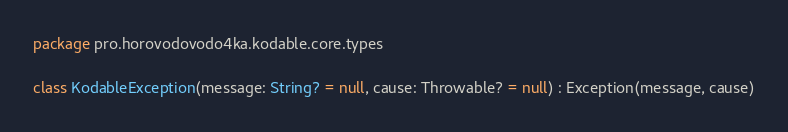Convert code to text. <code><loc_0><loc_0><loc_500><loc_500><_Kotlin_>package pro.horovodovodo4ka.kodable.core.types

class KodableException(message: String? = null, cause: Throwable? = null) : Exception(message, cause)</code> 